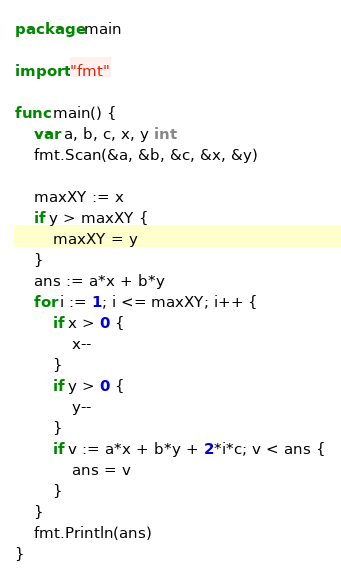<code> <loc_0><loc_0><loc_500><loc_500><_Go_>package main

import "fmt"

func main() {
	var a, b, c, x, y int
	fmt.Scan(&a, &b, &c, &x, &y)

	maxXY := x
	if y > maxXY {
		maxXY = y
	}
	ans := a*x + b*y
	for i := 1; i <= maxXY; i++ {
		if x > 0 {
			x--
		}
		if y > 0 {
			y--
		}
		if v := a*x + b*y + 2*i*c; v < ans {
			ans = v
		}
	}
	fmt.Println(ans)
}
</code> 